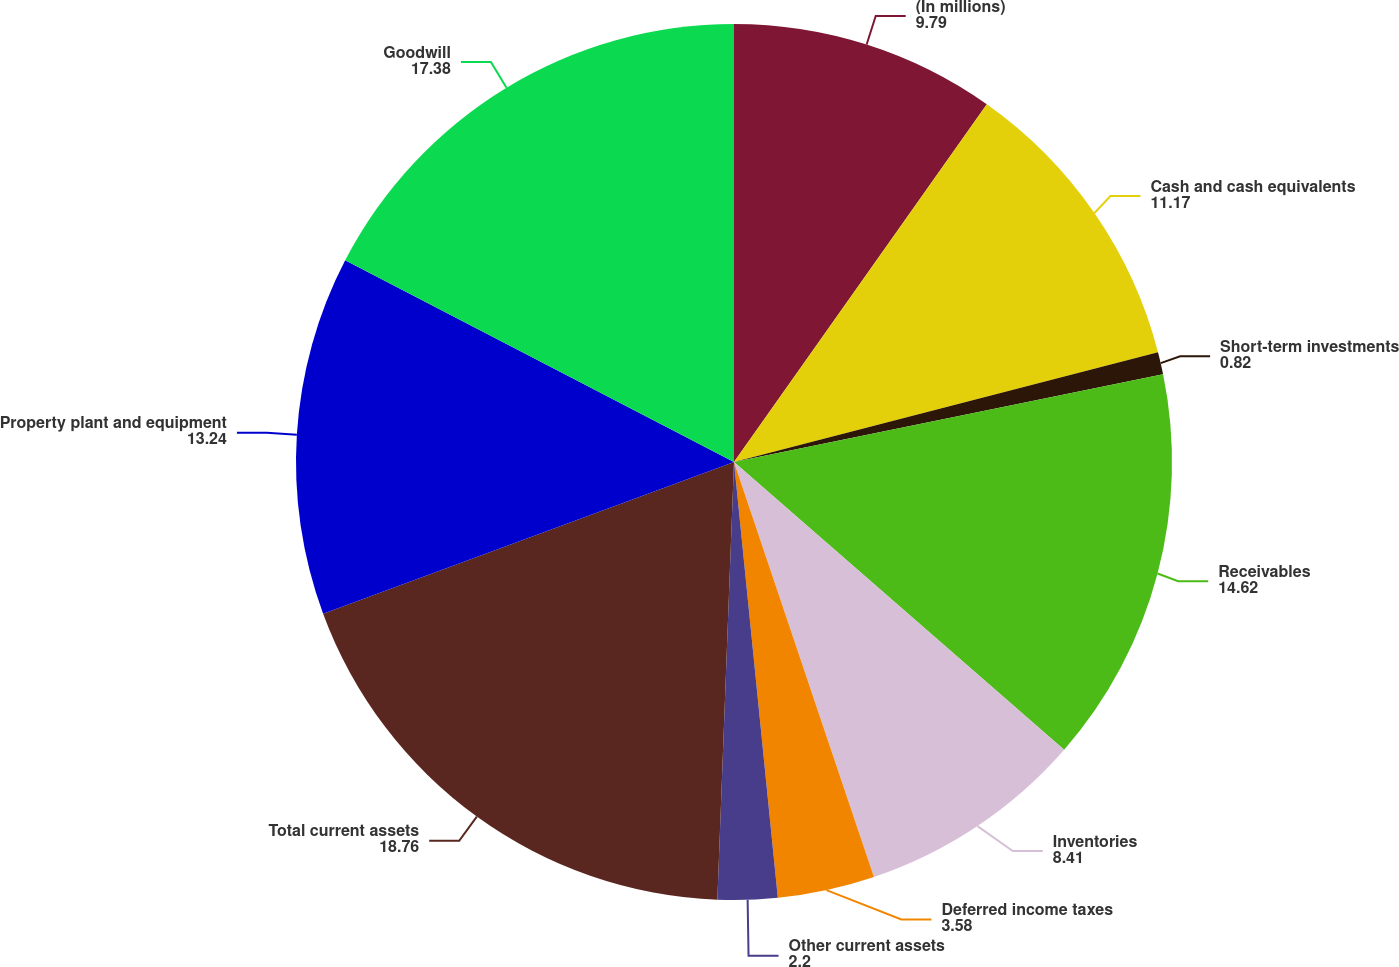Convert chart to OTSL. <chart><loc_0><loc_0><loc_500><loc_500><pie_chart><fcel>(In millions)<fcel>Cash and cash equivalents<fcel>Short-term investments<fcel>Receivables<fcel>Inventories<fcel>Deferred income taxes<fcel>Other current assets<fcel>Total current assets<fcel>Property plant and equipment<fcel>Goodwill<nl><fcel>9.79%<fcel>11.17%<fcel>0.82%<fcel>14.62%<fcel>8.41%<fcel>3.58%<fcel>2.2%<fcel>18.76%<fcel>13.24%<fcel>17.38%<nl></chart> 